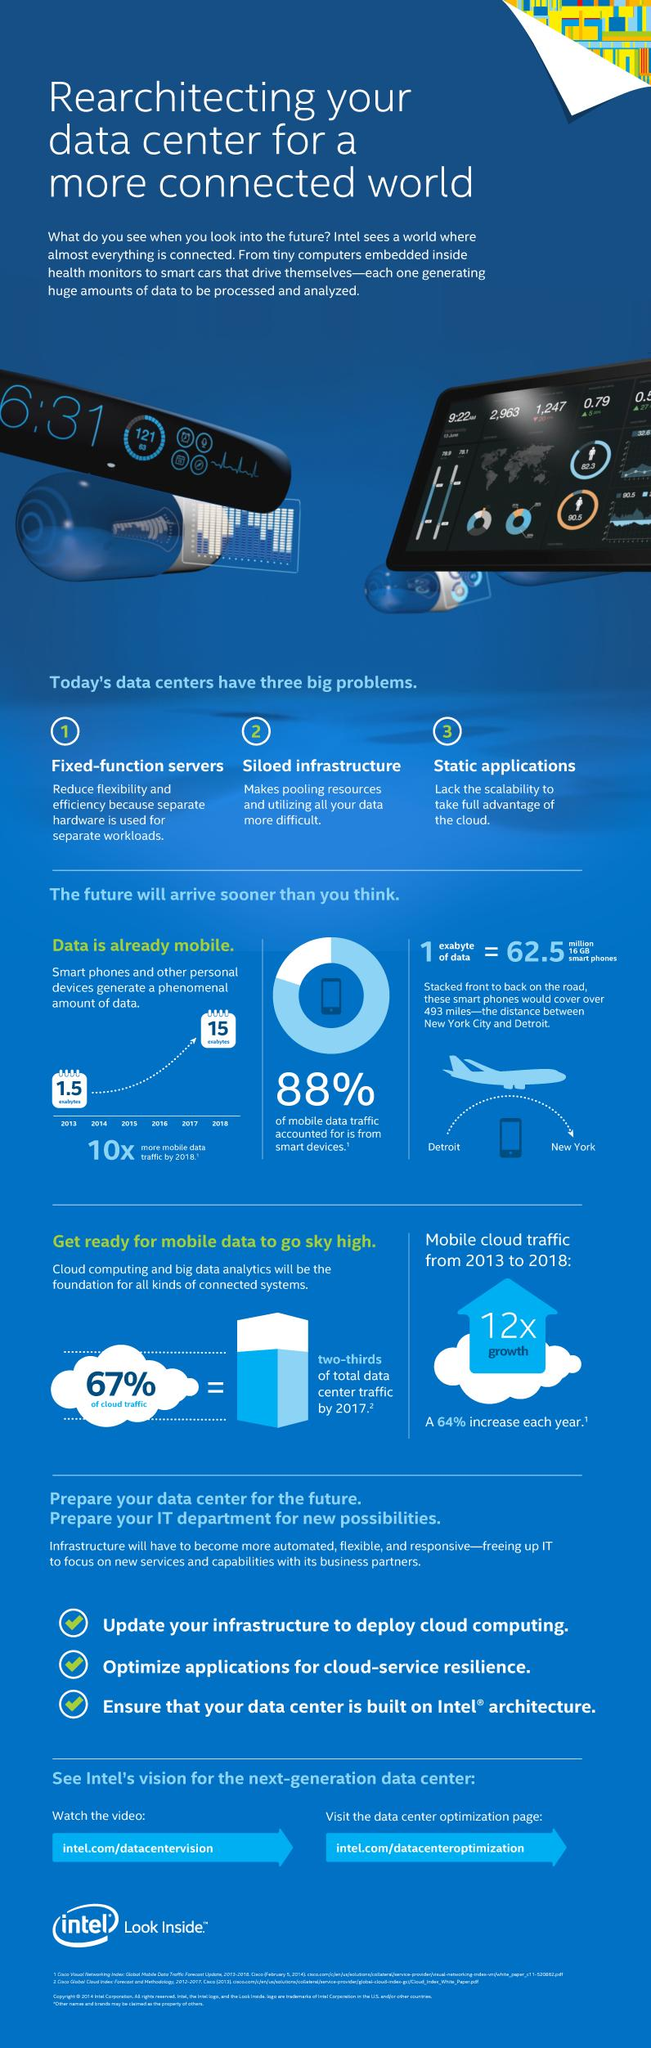Mention a couple of crucial points in this snapshot. According to a recent study, 33% of all internet traffic is generated by cloud-based services. Approximately 12% of mobile data traffic is not generated by smart devices. 